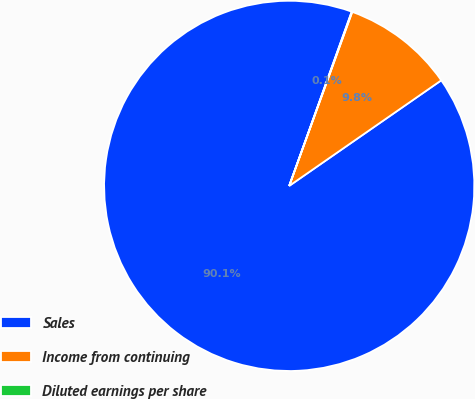Convert chart. <chart><loc_0><loc_0><loc_500><loc_500><pie_chart><fcel>Sales<fcel>Income from continuing<fcel>Diluted earnings per share<nl><fcel>90.13%<fcel>9.81%<fcel>0.05%<nl></chart> 